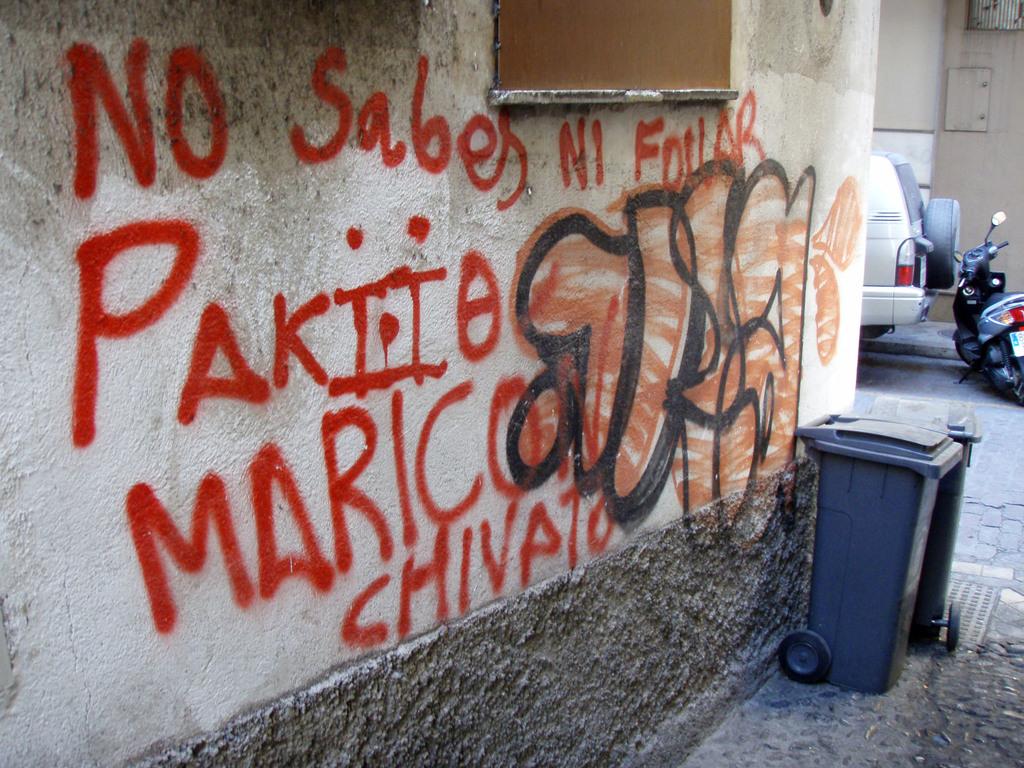What word is written in red on the bottom of the wall?
Keep it short and to the point. Chivato. 